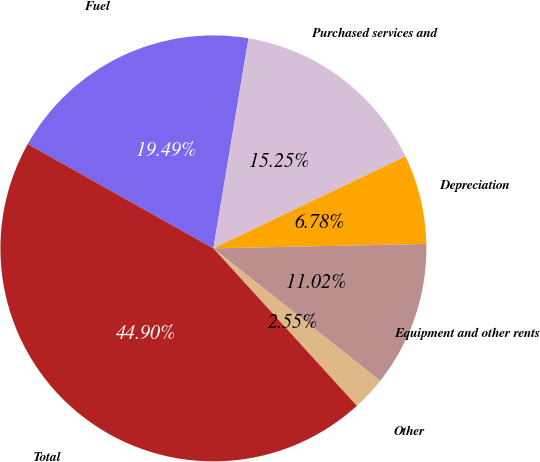<chart> <loc_0><loc_0><loc_500><loc_500><pie_chart><fcel>Fuel<fcel>Purchased services and<fcel>Depreciation<fcel>Equipment and other rents<fcel>Other<fcel>Total<nl><fcel>19.49%<fcel>15.25%<fcel>6.78%<fcel>11.02%<fcel>2.55%<fcel>44.9%<nl></chart> 